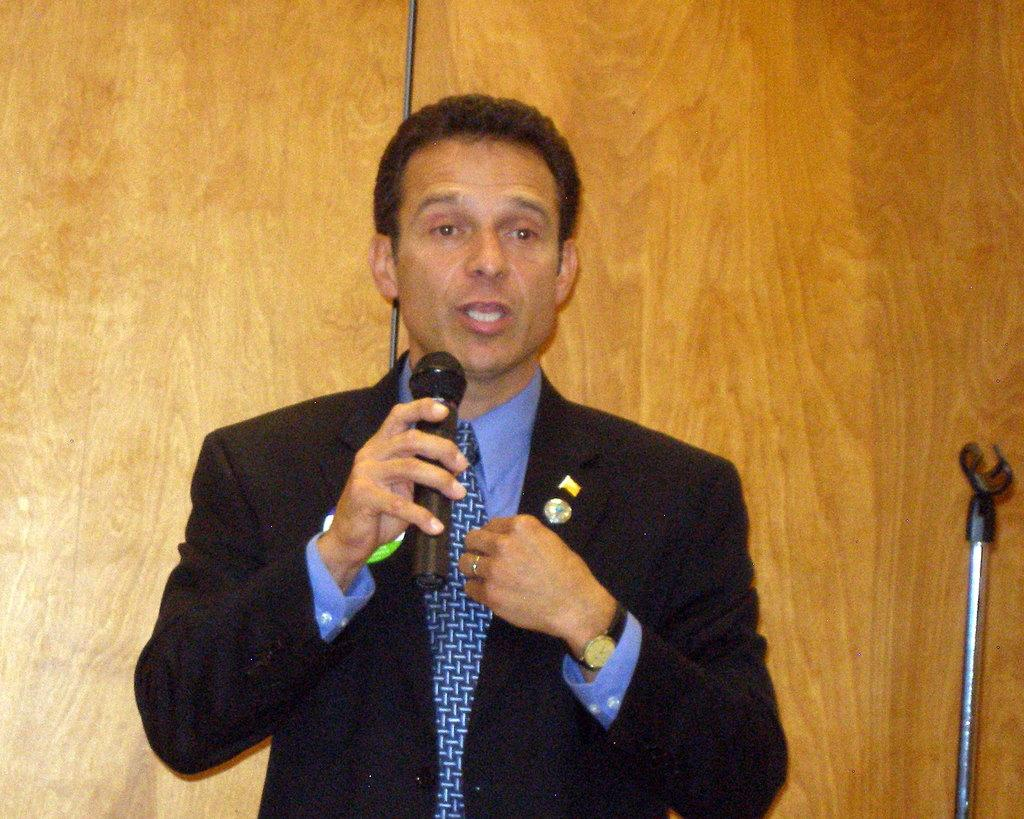What is the man in the image holding in his right hand? The man is holding a mic in his right hand. What is the man wearing on his upper body? The man is wearing a black dress. What type of accessory is the man wearing around his neck? The man is wearing a blue tie. What can be seen on the man's left hand? The man is wearing a watch on his left hand. What is the title of the degree the man is holding in the image? There is no degree present in the image; the man is holding a mic. 